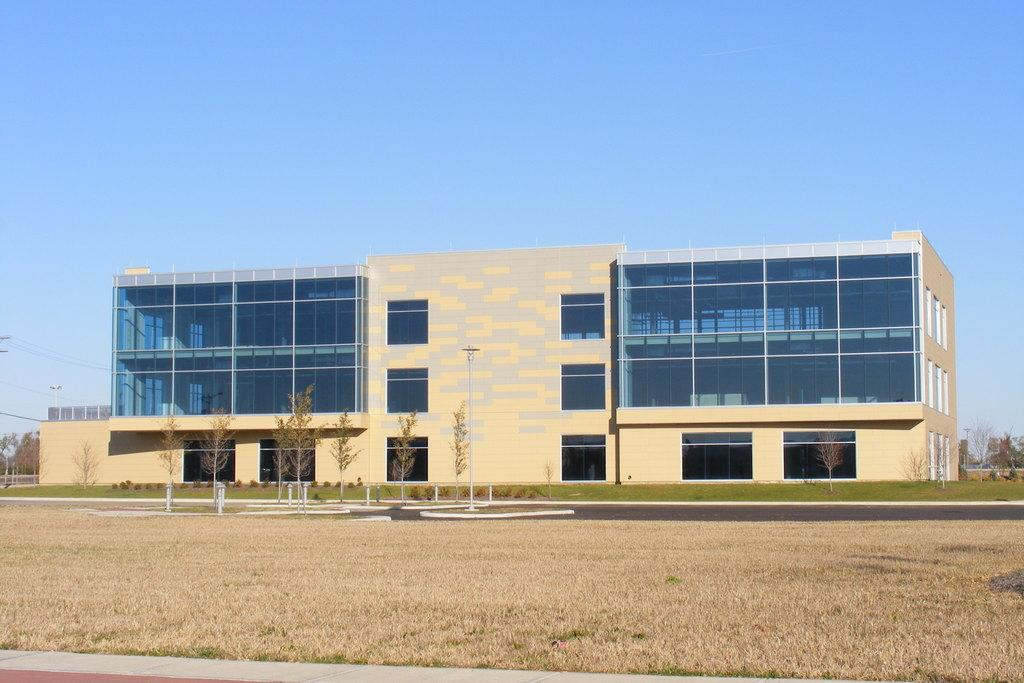What type of vegetation is present in the image? There is dried grass in the image. What can be seen in the background of the image? There is a building, grass, trees, and the sky visible in the background of the image. How much profit can be made from the cattle in the image? There are no cattle present in the image, so it is not possible to determine any potential profit. 